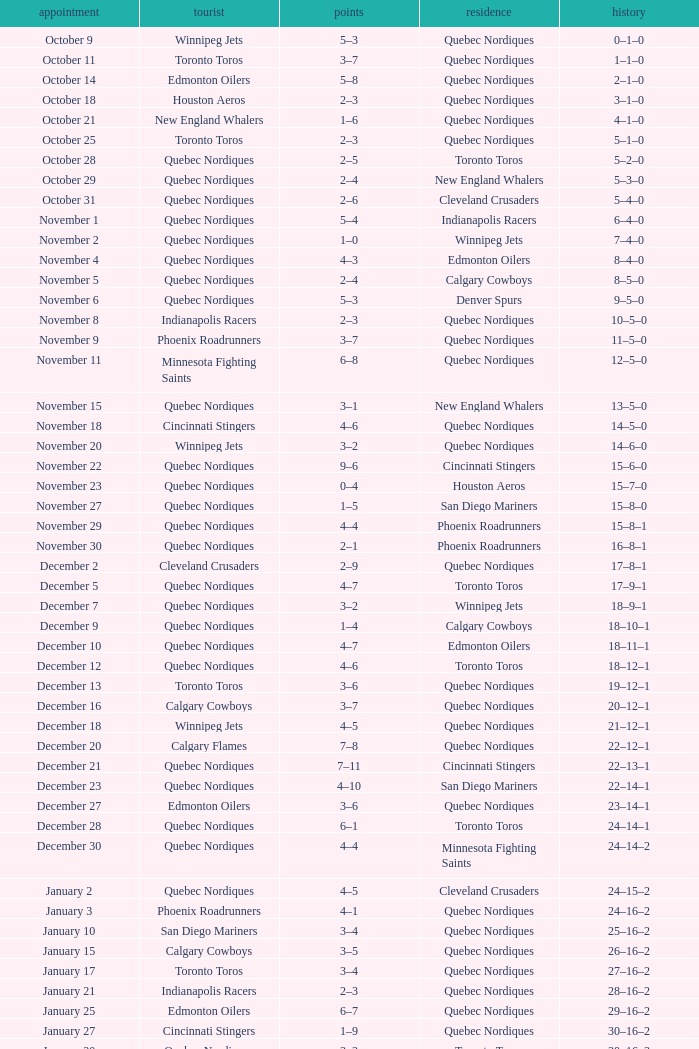What was the date of the game with a score of 2–1? November 30. 